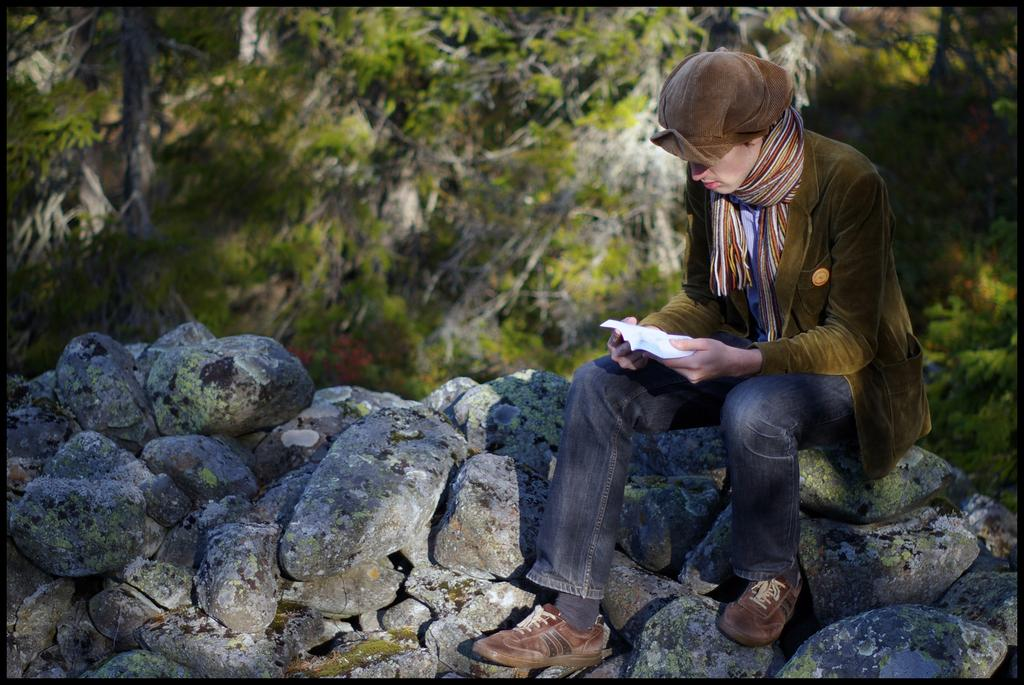What is the person in the image doing? There is a person sitting on a rock in the image. What is the person holding in his hand? The person is holding an object in his hand. What type of natural environment is depicted in the image? There are many trees and rocks in the image, suggesting a natural setting. Can you describe the kitten playing with the cloud in the image? There is no kitten or cloud present in the image. What type of pets can be seen accompanying the person in the image? There are no pets visible in the image; only the person and the object he is holding can be seen. 